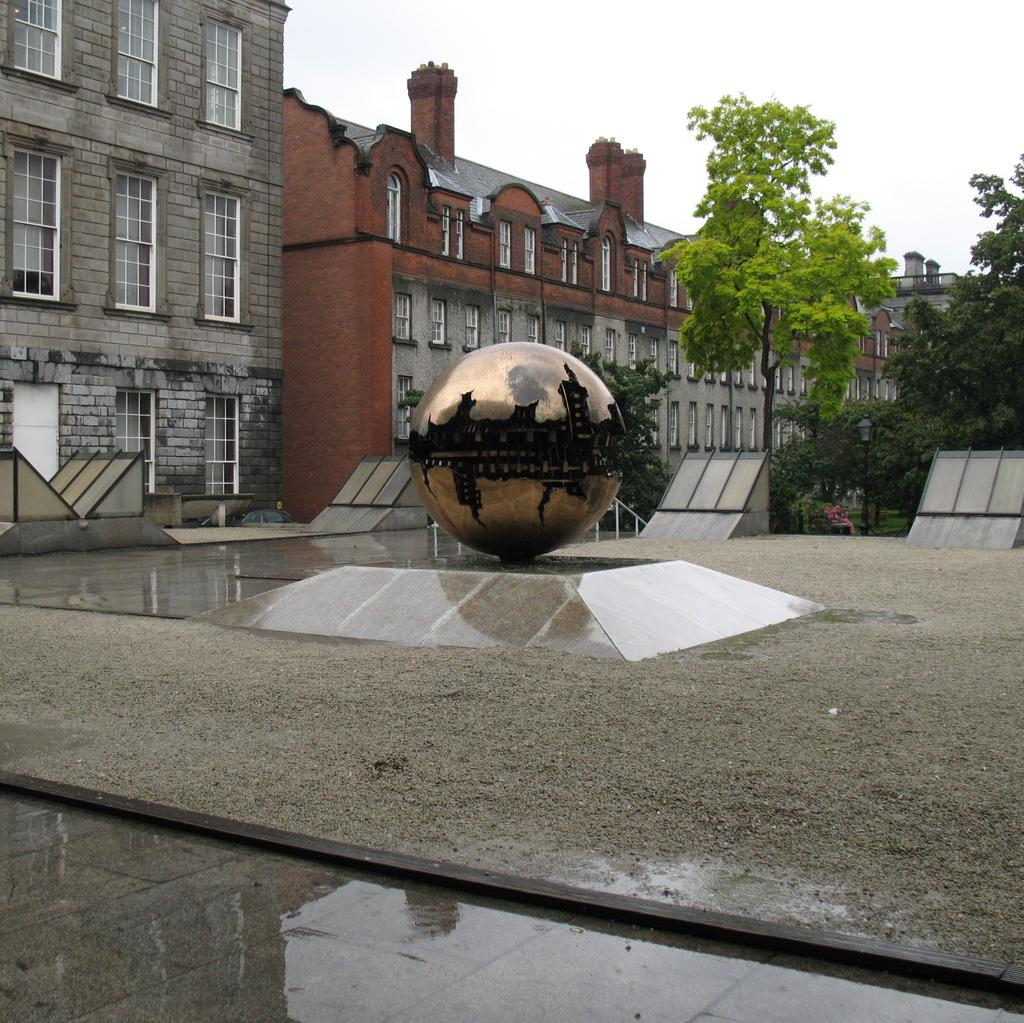What is the main object on the platform in the image? There is a circular object on a platform in the image. What can be seen beneath the platform? The ground is visible in the platform is standing on is visible in the image. What type of natural elements are present in the image? There are trees in the image. What type of man-made structures can be seen in the image? There are buildings in the image. What feature is present on the buildings? Windows are present in the image. Are there any other objects in the image besides the circular object and the buildings? Yes, there are other objects in the image. What is visible in the background of the image? The sky is visible in the background of the image. What type of blade is being used to cut the trees in the image? There is no blade or tree-cutting activity present in the image; it features a circular object on a platform, buildings, trees, and the sky. 